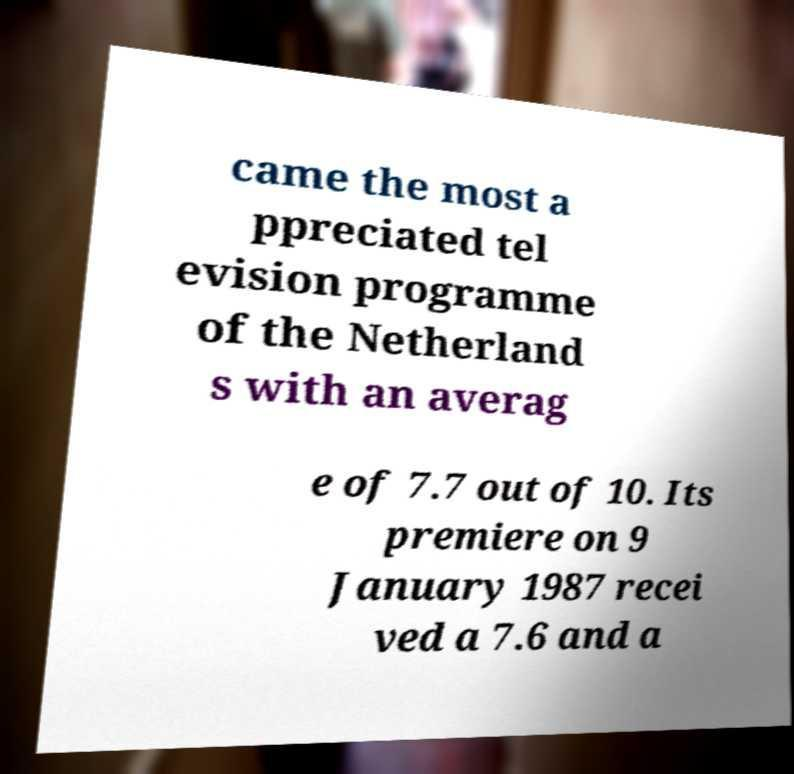What messages or text are displayed in this image? I need them in a readable, typed format. came the most a ppreciated tel evision programme of the Netherland s with an averag e of 7.7 out of 10. Its premiere on 9 January 1987 recei ved a 7.6 and a 